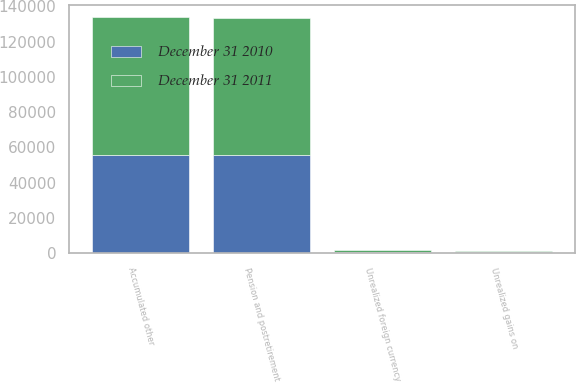<chart> <loc_0><loc_0><loc_500><loc_500><stacked_bar_chart><ecel><fcel>Unrealized gains on<fcel>Unrealized foreign currency<fcel>Pension and postretirement<fcel>Accumulated other<nl><fcel>December 31 2011<fcel>269<fcel>975<fcel>77581<fcel>78287<nl><fcel>December 31 2010<fcel>725<fcel>792<fcel>55736<fcel>55803<nl></chart> 